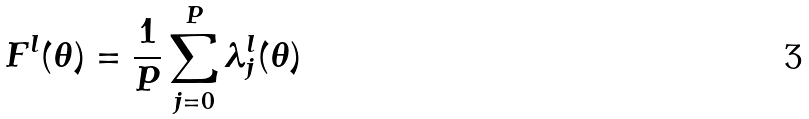Convert formula to latex. <formula><loc_0><loc_0><loc_500><loc_500>F ^ { l } ( \theta ) = \frac { 1 } { P } \sum _ { j = 0 } ^ { P } \lambda _ { j } ^ { l } ( \theta )</formula> 